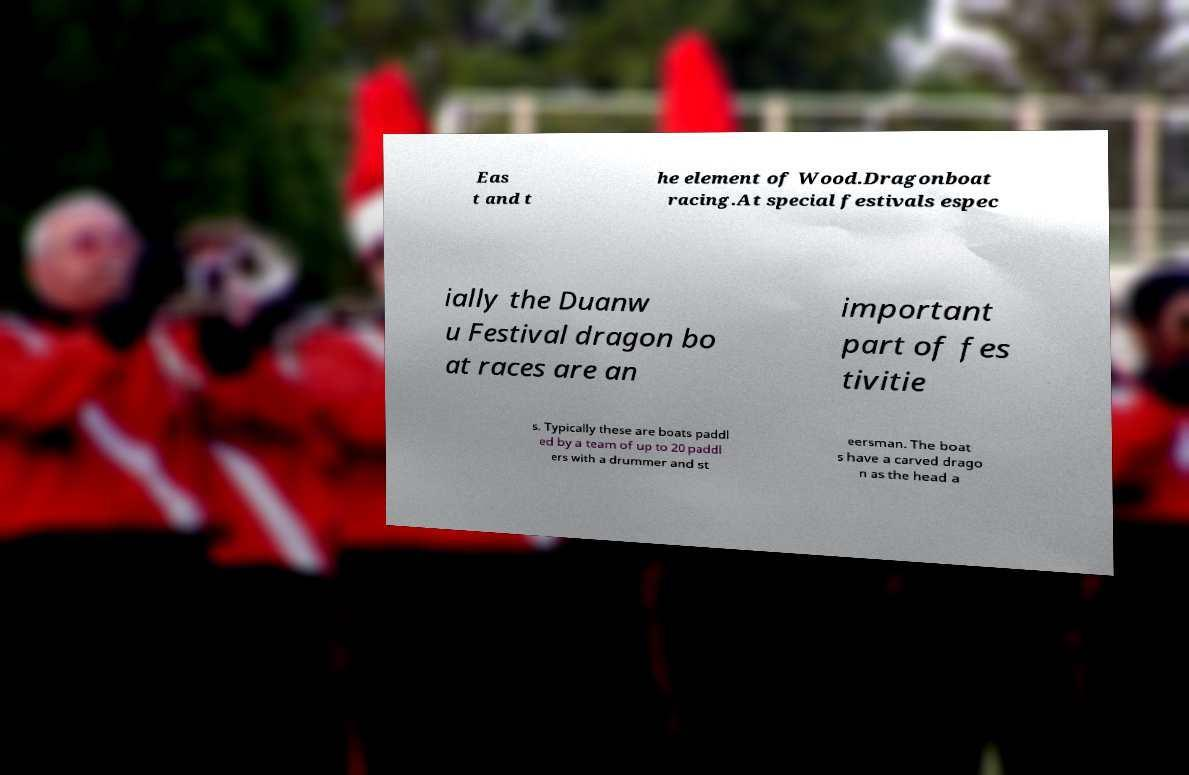Can you accurately transcribe the text from the provided image for me? Eas t and t he element of Wood.Dragonboat racing.At special festivals espec ially the Duanw u Festival dragon bo at races are an important part of fes tivitie s. Typically these are boats paddl ed by a team of up to 20 paddl ers with a drummer and st eersman. The boat s have a carved drago n as the head a 